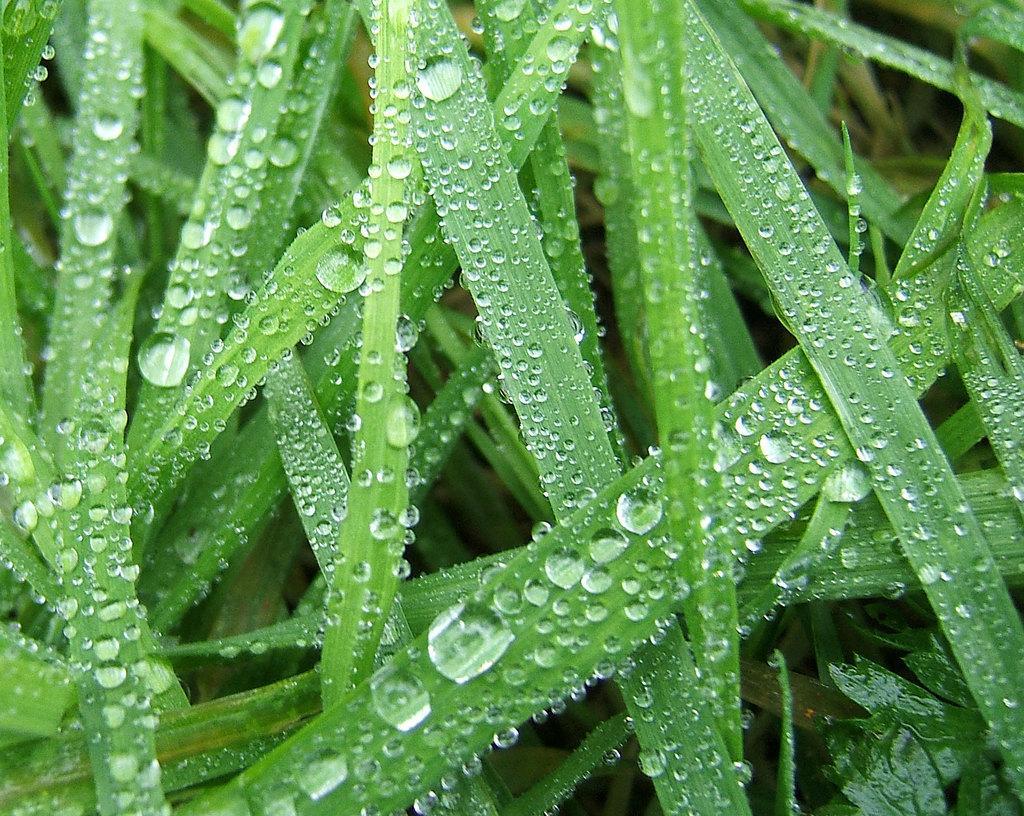Describe this image in one or two sentences. In this image we can see the dew on the grass. 